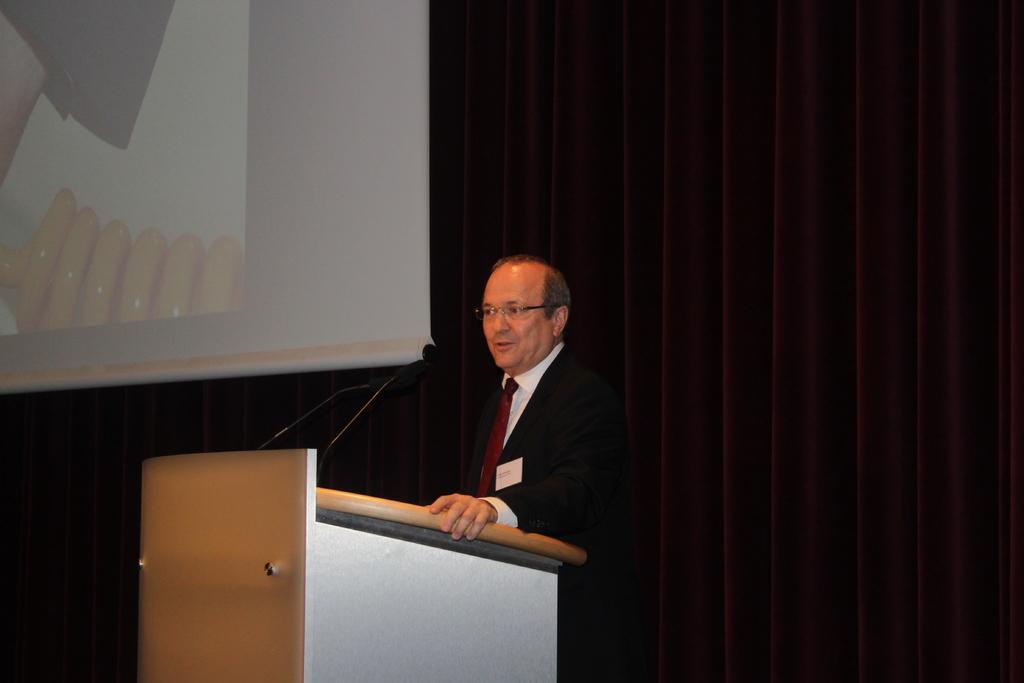In one or two sentences, can you explain what this image depicts? In the center of the image a man is standing in-front of podium. On podium we can see the mics. In the background of the image we can screen, curtain are there. 